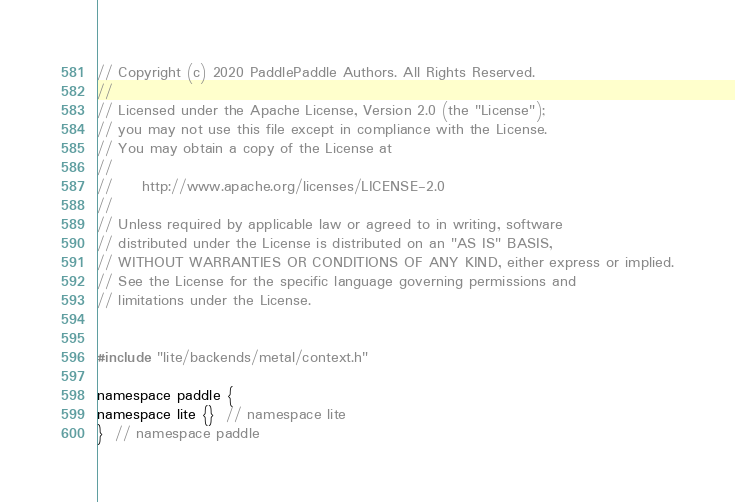Convert code to text. <code><loc_0><loc_0><loc_500><loc_500><_ObjectiveC_>// Copyright (c) 2020 PaddlePaddle Authors. All Rights Reserved.
//
// Licensed under the Apache License, Version 2.0 (the "License");
// you may not use this file except in compliance with the License.
// You may obtain a copy of the License at
//
//     http://www.apache.org/licenses/LICENSE-2.0
//
// Unless required by applicable law or agreed to in writing, software
// distributed under the License is distributed on an "AS IS" BASIS,
// WITHOUT WARRANTIES OR CONDITIONS OF ANY KIND, either express or implied.
// See the License for the specific language governing permissions and
// limitations under the License.


#include "lite/backends/metal/context.h"

namespace paddle {
namespace lite {}  // namespace lite
}  // namespace paddle
</code> 